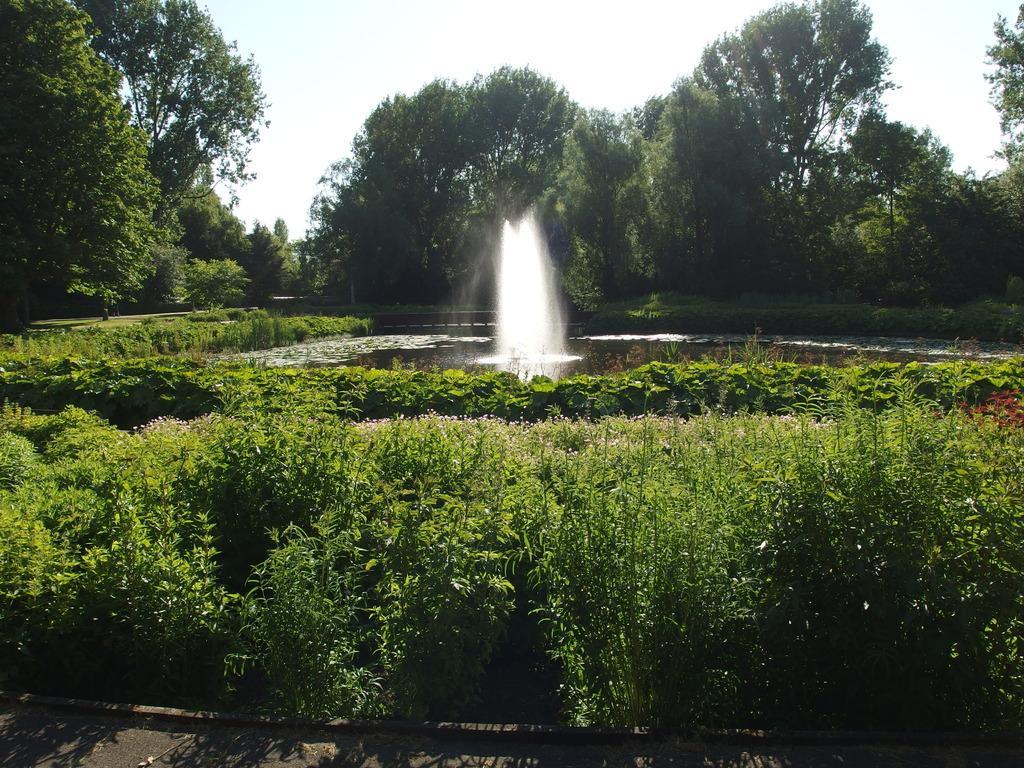How would you summarize this image in a sentence or two? In the center of the image there is a fountain. In front of the image there is a road. There are plants. In the background of the image there are trees and sky. 